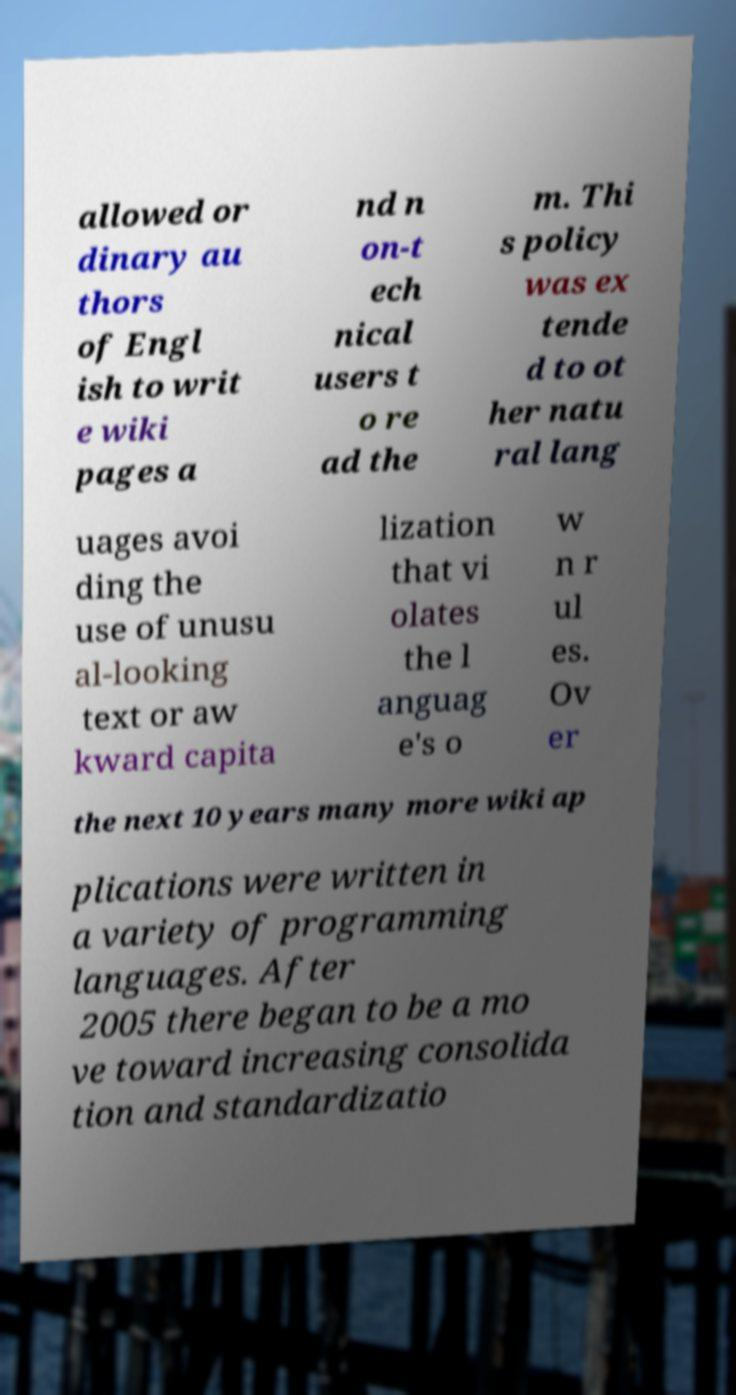Can you accurately transcribe the text from the provided image for me? allowed or dinary au thors of Engl ish to writ e wiki pages a nd n on-t ech nical users t o re ad the m. Thi s policy was ex tende d to ot her natu ral lang uages avoi ding the use of unusu al-looking text or aw kward capita lization that vi olates the l anguag e's o w n r ul es. Ov er the next 10 years many more wiki ap plications were written in a variety of programming languages. After 2005 there began to be a mo ve toward increasing consolida tion and standardizatio 